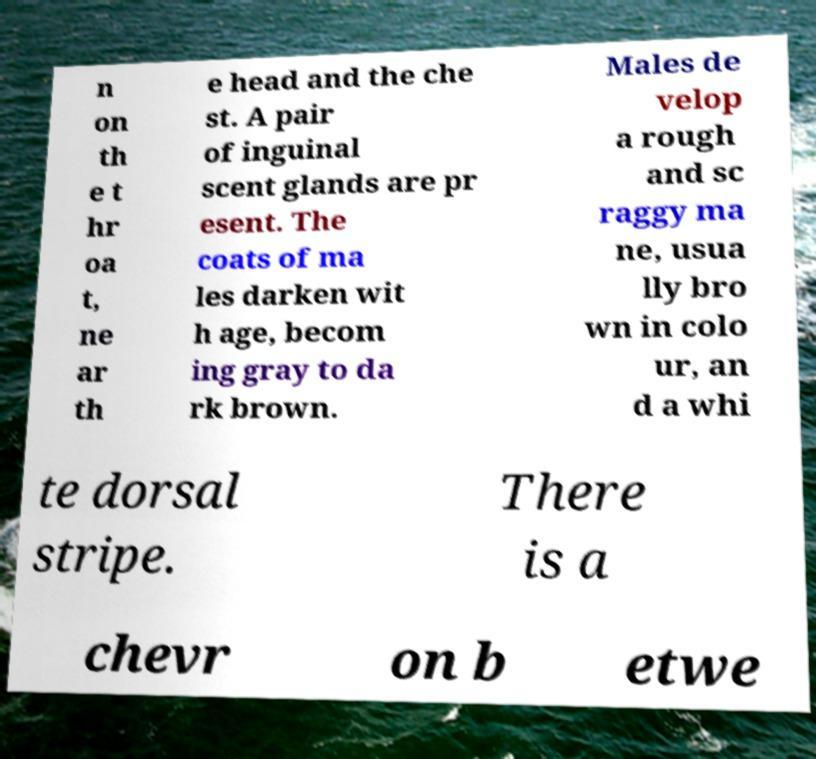What messages or text are displayed in this image? I need them in a readable, typed format. n on th e t hr oa t, ne ar th e head and the che st. A pair of inguinal scent glands are pr esent. The coats of ma les darken wit h age, becom ing gray to da rk brown. Males de velop a rough and sc raggy ma ne, usua lly bro wn in colo ur, an d a whi te dorsal stripe. There is a chevr on b etwe 